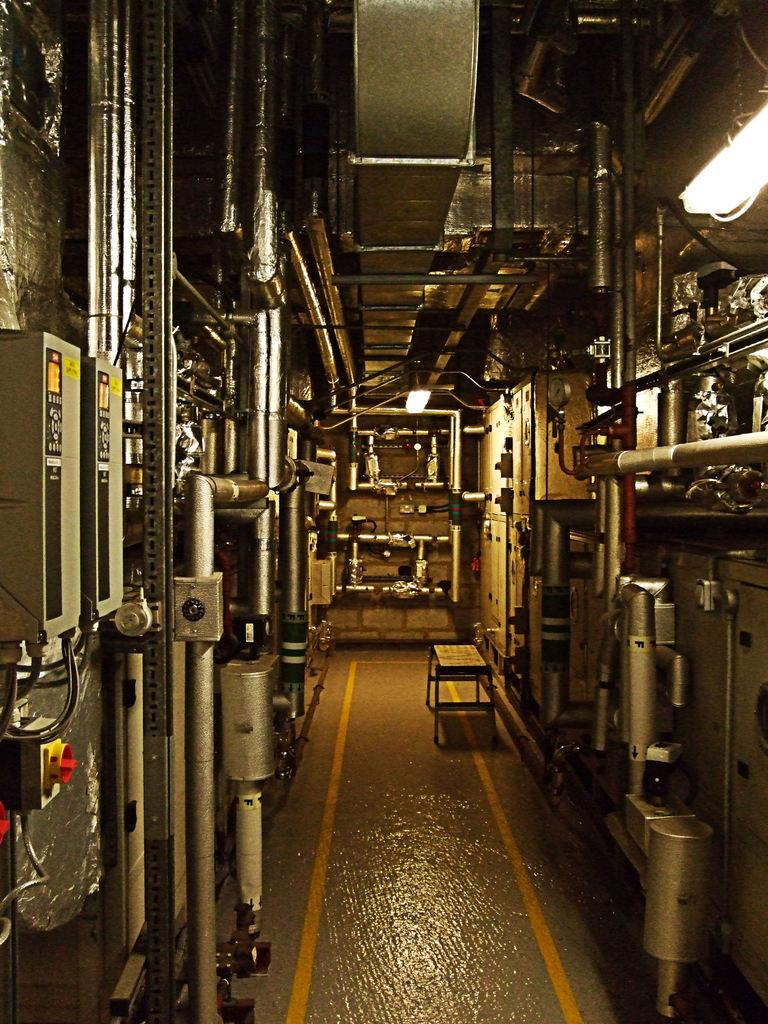What objects in the image are related to machinery or technology? There are machines in the image. What type of furniture is present in the image? There is a small table in the image. Can you describe the lighting conditions in the image? There is light visible in the image. What historical event is being commemorated by the machines in the image? There is no indication of a historical event being commemorated in the image; it simply features machines and a small table. How much money is being exchanged between the machines in the image? There is no exchange of money between the machines in the image. 